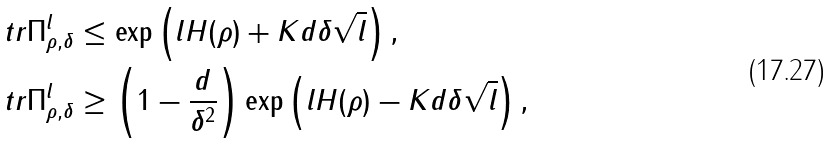Convert formula to latex. <formula><loc_0><loc_0><loc_500><loc_500>\ t r \Pi ^ { l } _ { \rho , \delta } & \leq \exp \left ( l H ( \rho ) + K d \delta \sqrt { l } \right ) , \\ \ t r \Pi ^ { l } _ { \rho , \delta } & \geq \left ( 1 - \frac { d } { \delta ^ { 2 } } \right ) \exp \left ( l H ( \rho ) - K d \delta \sqrt { l } \right ) ,</formula> 